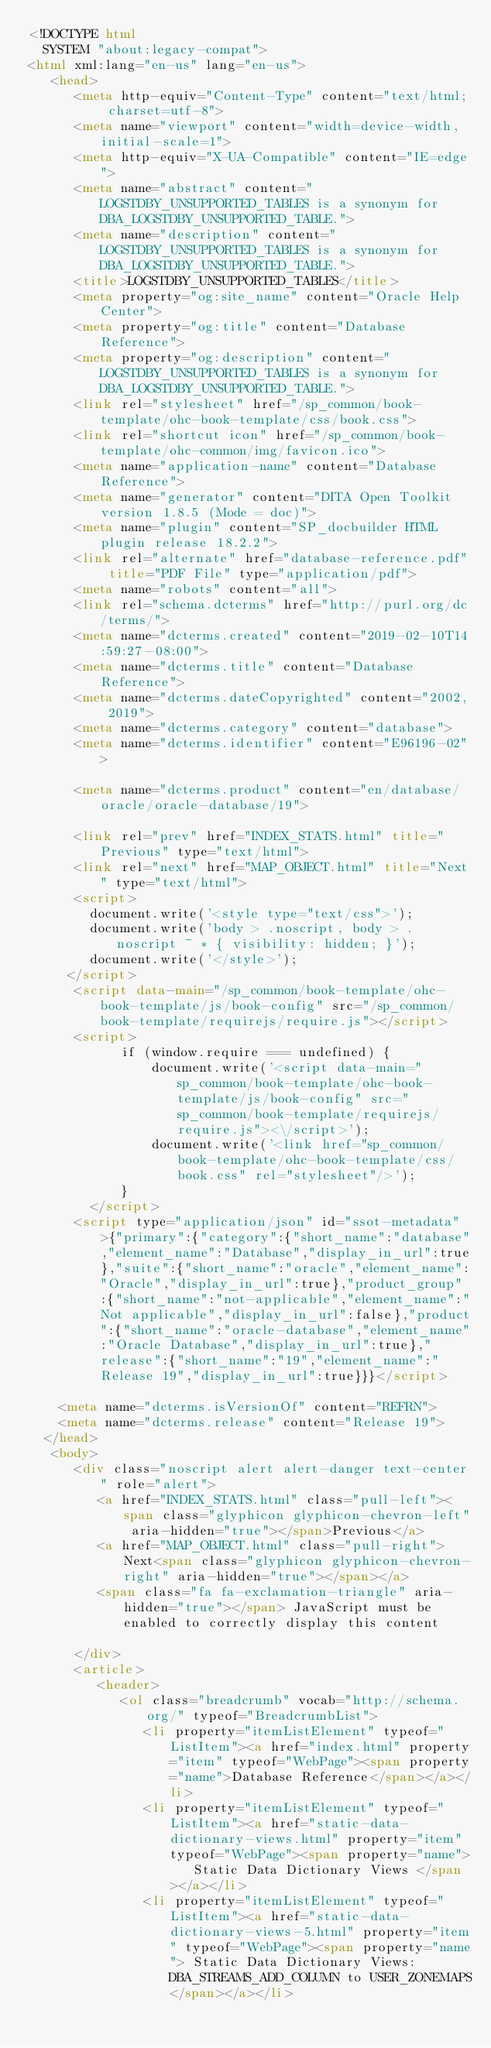Convert code to text. <code><loc_0><loc_0><loc_500><loc_500><_HTML_><!DOCTYPE html
  SYSTEM "about:legacy-compat">
<html xml:lang="en-us" lang="en-us">
   <head>
      <meta http-equiv="Content-Type" content="text/html; charset=utf-8">
      <meta name="viewport" content="width=device-width, initial-scale=1">
      <meta http-equiv="X-UA-Compatible" content="IE=edge">
      <meta name="abstract" content="LOGSTDBY_UNSUPPORTED_TABLES is a synonym for DBA_LOGSTDBY_UNSUPPORTED_TABLE.">
      <meta name="description" content="LOGSTDBY_UNSUPPORTED_TABLES is a synonym for DBA_LOGSTDBY_UNSUPPORTED_TABLE.">
      <title>LOGSTDBY_UNSUPPORTED_TABLES</title>
      <meta property="og:site_name" content="Oracle Help Center">
      <meta property="og:title" content="Database Reference">
      <meta property="og:description" content="LOGSTDBY_UNSUPPORTED_TABLES is a synonym for DBA_LOGSTDBY_UNSUPPORTED_TABLE.">
      <link rel="stylesheet" href="/sp_common/book-template/ohc-book-template/css/book.css">
      <link rel="shortcut icon" href="/sp_common/book-template/ohc-common/img/favicon.ico">
      <meta name="application-name" content="Database Reference">
      <meta name="generator" content="DITA Open Toolkit version 1.8.5 (Mode = doc)">
      <meta name="plugin" content="SP_docbuilder HTML plugin release 18.2.2">
      <link rel="alternate" href="database-reference.pdf" title="PDF File" type="application/pdf">
      <meta name="robots" content="all">
      <link rel="schema.dcterms" href="http://purl.org/dc/terms/">
      <meta name="dcterms.created" content="2019-02-10T14:59:27-08:00">
      <meta name="dcterms.title" content="Database Reference">
      <meta name="dcterms.dateCopyrighted" content="2002, 2019">
      <meta name="dcterms.category" content="database">
      <meta name="dcterms.identifier" content="E96196-02">
      
      <meta name="dcterms.product" content="en/database/oracle/oracle-database/19">
      
      <link rel="prev" href="INDEX_STATS.html" title="Previous" type="text/html">
      <link rel="next" href="MAP_OBJECT.html" title="Next" type="text/html">
      <script>
        document.write('<style type="text/css">');
        document.write('body > .noscript, body > .noscript ~ * { visibility: hidden; }');
        document.write('</style>');
     </script>
      <script data-main="/sp_common/book-template/ohc-book-template/js/book-config" src="/sp_common/book-template/requirejs/require.js"></script>
      <script>
            if (window.require === undefined) {
                document.write('<script data-main="sp_common/book-template/ohc-book-template/js/book-config" src="sp_common/book-template/requirejs/require.js"><\/script>');
                document.write('<link href="sp_common/book-template/ohc-book-template/css/book.css" rel="stylesheet"/>');
            }
        </script>
      <script type="application/json" id="ssot-metadata">{"primary":{"category":{"short_name":"database","element_name":"Database","display_in_url":true},"suite":{"short_name":"oracle","element_name":"Oracle","display_in_url":true},"product_group":{"short_name":"not-applicable","element_name":"Not applicable","display_in_url":false},"product":{"short_name":"oracle-database","element_name":"Oracle Database","display_in_url":true},"release":{"short_name":"19","element_name":"Release 19","display_in_url":true}}}</script>
      
    <meta name="dcterms.isVersionOf" content="REFRN">
    <meta name="dcterms.release" content="Release 19">
  </head>
   <body>
      <div class="noscript alert alert-danger text-center" role="alert">
         <a href="INDEX_STATS.html" class="pull-left"><span class="glyphicon glyphicon-chevron-left" aria-hidden="true"></span>Previous</a>
         <a href="MAP_OBJECT.html" class="pull-right">Next<span class="glyphicon glyphicon-chevron-right" aria-hidden="true"></span></a>
         <span class="fa fa-exclamation-triangle" aria-hidden="true"></span> JavaScript must be enabled to correctly display this content
        
      </div>
      <article>
         <header>
            <ol class="breadcrumb" vocab="http://schema.org/" typeof="BreadcrumbList">
               <li property="itemListElement" typeof="ListItem"><a href="index.html" property="item" typeof="WebPage"><span property="name">Database Reference</span></a></li>
               <li property="itemListElement" typeof="ListItem"><a href="static-data-dictionary-views.html" property="item" typeof="WebPage"><span property="name">   Static Data Dictionary Views </span></a></li>
               <li property="itemListElement" typeof="ListItem"><a href="static-data-dictionary-views-5.html" property="item" typeof="WebPage"><span property="name"> Static Data Dictionary Views: DBA_STREAMS_ADD_COLUMN to USER_ZONEMAPS</span></a></li></code> 